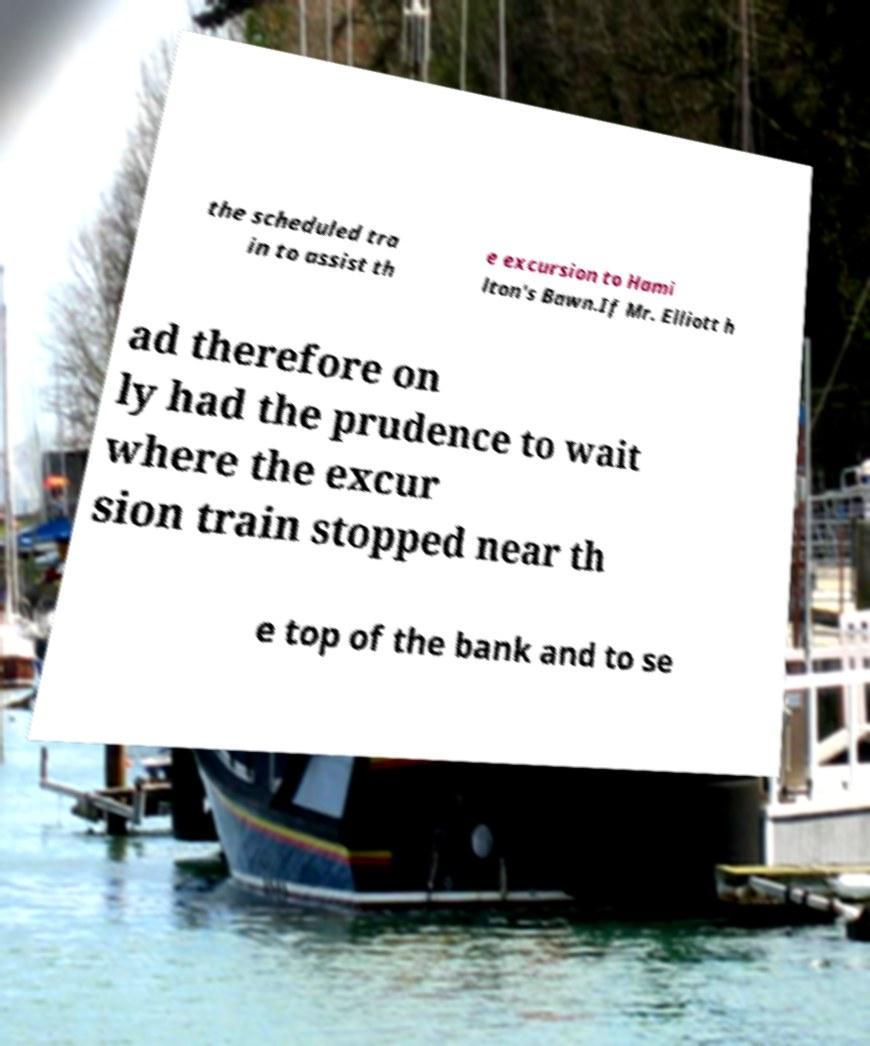Could you assist in decoding the text presented in this image and type it out clearly? the scheduled tra in to assist th e excursion to Hami lton's Bawn.If Mr. Elliott h ad therefore on ly had the prudence to wait where the excur sion train stopped near th e top of the bank and to se 